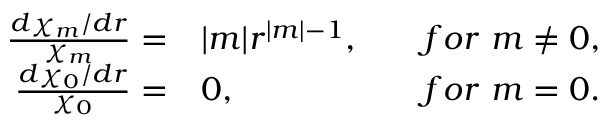Convert formula to latex. <formula><loc_0><loc_0><loc_500><loc_500>\begin{array} { r l r } { \frac { d \chi _ { m } / d r } { \chi _ { m } } = } & | m | r ^ { | m | - 1 } , } & { f o r m \not = 0 , } \\ { \frac { d \chi _ { 0 } / d r } { \chi _ { 0 } } = } & 0 , } & { f o r m = 0 . } \end{array}</formula> 